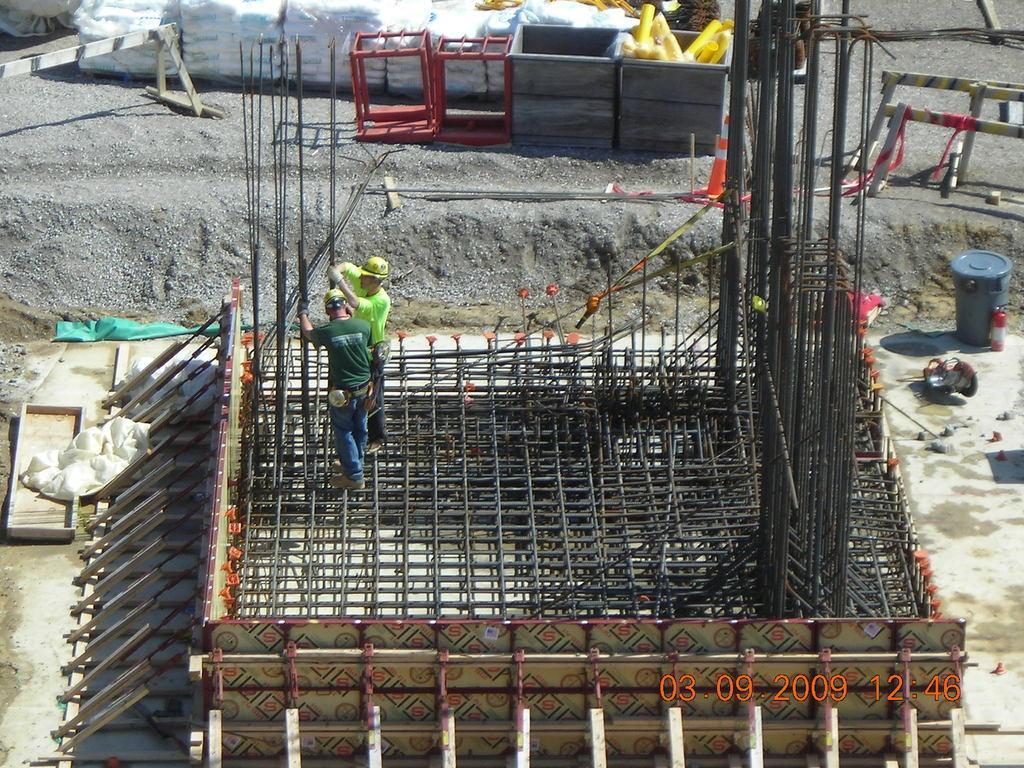How would you summarize this image in a sentence or two? In this picture there are two persons standing and holding the rods. In the foreground there are rods. At the back there are objects and bags and there is a fire extinguisher and there is a drum and there are sheets. 